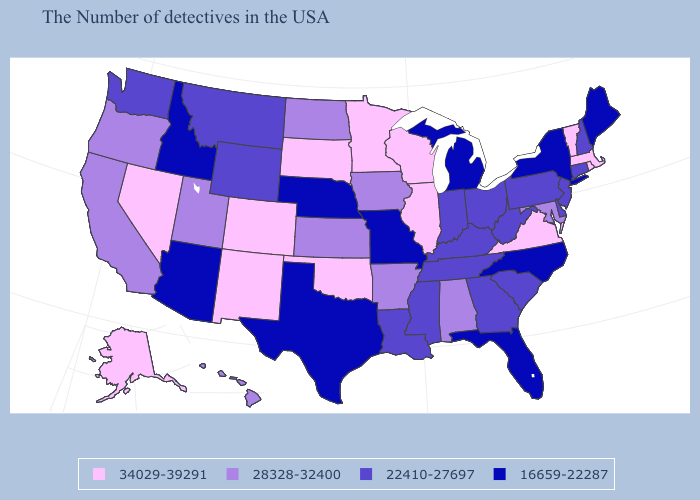Among the states that border New Jersey , which have the highest value?
Short answer required. Delaware, Pennsylvania. Name the states that have a value in the range 28328-32400?
Answer briefly. Maryland, Alabama, Arkansas, Iowa, Kansas, North Dakota, Utah, California, Oregon, Hawaii. Which states have the highest value in the USA?
Answer briefly. Massachusetts, Rhode Island, Vermont, Virginia, Wisconsin, Illinois, Minnesota, Oklahoma, South Dakota, Colorado, New Mexico, Nevada, Alaska. Name the states that have a value in the range 22410-27697?
Answer briefly. New Hampshire, Connecticut, New Jersey, Delaware, Pennsylvania, South Carolina, West Virginia, Ohio, Georgia, Kentucky, Indiana, Tennessee, Mississippi, Louisiana, Wyoming, Montana, Washington. Which states hav the highest value in the MidWest?
Quick response, please. Wisconsin, Illinois, Minnesota, South Dakota. Among the states that border Ohio , does Kentucky have the highest value?
Be succinct. Yes. What is the value of Connecticut?
Be succinct. 22410-27697. Which states have the lowest value in the West?
Concise answer only. Arizona, Idaho. Which states hav the highest value in the Northeast?
Quick response, please. Massachusetts, Rhode Island, Vermont. Among the states that border North Carolina , which have the lowest value?
Concise answer only. South Carolina, Georgia, Tennessee. What is the highest value in the West ?
Write a very short answer. 34029-39291. Does Massachusetts have the same value as Nevada?
Quick response, please. Yes. Does Maine have the lowest value in the Northeast?
Give a very brief answer. Yes. Does the first symbol in the legend represent the smallest category?
Short answer required. No. What is the value of Ohio?
Keep it brief. 22410-27697. 